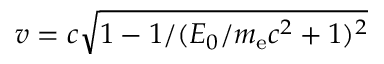Convert formula to latex. <formula><loc_0><loc_0><loc_500><loc_500>v = c \sqrt { 1 - 1 / ( E _ { 0 } / m _ { e } c ^ { 2 } + 1 ) ^ { 2 } }</formula> 